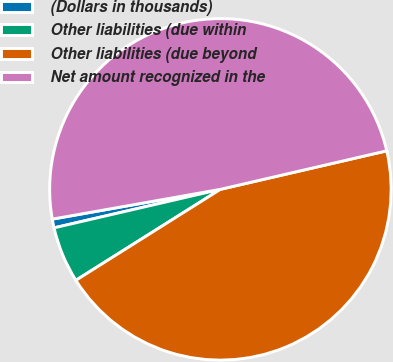Convert chart. <chart><loc_0><loc_0><loc_500><loc_500><pie_chart><fcel>(Dollars in thousands)<fcel>Other liabilities (due within<fcel>Other liabilities (due beyond<fcel>Net amount recognized in the<nl><fcel>0.83%<fcel>5.32%<fcel>44.68%<fcel>49.17%<nl></chart> 